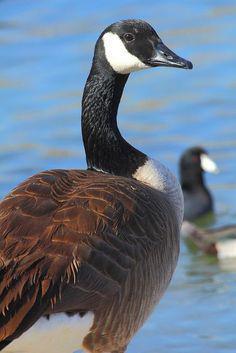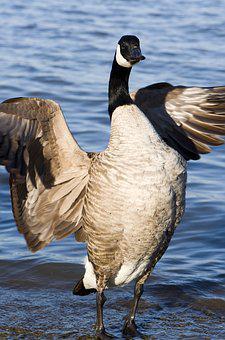The first image is the image on the left, the second image is the image on the right. For the images shown, is this caption "There are more than two birds total." true? Answer yes or no. Yes. 